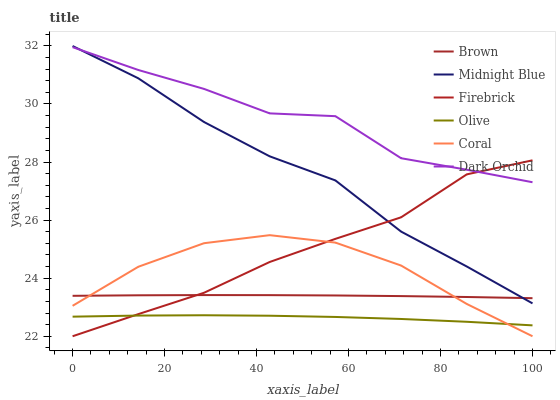Does Olive have the minimum area under the curve?
Answer yes or no. Yes. Does Dark Orchid have the maximum area under the curve?
Answer yes or no. Yes. Does Midnight Blue have the minimum area under the curve?
Answer yes or no. No. Does Midnight Blue have the maximum area under the curve?
Answer yes or no. No. Is Brown the smoothest?
Answer yes or no. Yes. Is Dark Orchid the roughest?
Answer yes or no. Yes. Is Midnight Blue the smoothest?
Answer yes or no. No. Is Midnight Blue the roughest?
Answer yes or no. No. Does Firebrick have the lowest value?
Answer yes or no. Yes. Does Midnight Blue have the lowest value?
Answer yes or no. No. Does Midnight Blue have the highest value?
Answer yes or no. Yes. Does Firebrick have the highest value?
Answer yes or no. No. Is Olive less than Brown?
Answer yes or no. Yes. Is Dark Orchid greater than Brown?
Answer yes or no. Yes. Does Firebrick intersect Brown?
Answer yes or no. Yes. Is Firebrick less than Brown?
Answer yes or no. No. Is Firebrick greater than Brown?
Answer yes or no. No. Does Olive intersect Brown?
Answer yes or no. No. 